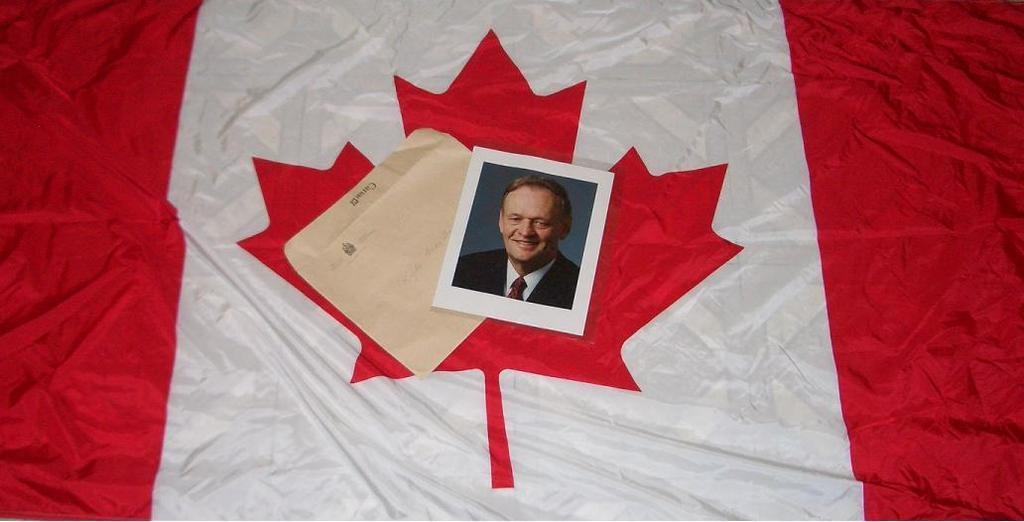What is the main subject of the image? The main subject of the image is a photo. What other objects are present in the image? There is an envelope and a cloth in the image. What type of wing is visible on the photo in the image? There is no wing visible on the photo in the image. What design elements can be seen on the cloth in the image? The provided facts do not mention any design elements on the cloth, so we cannot answer this question. 